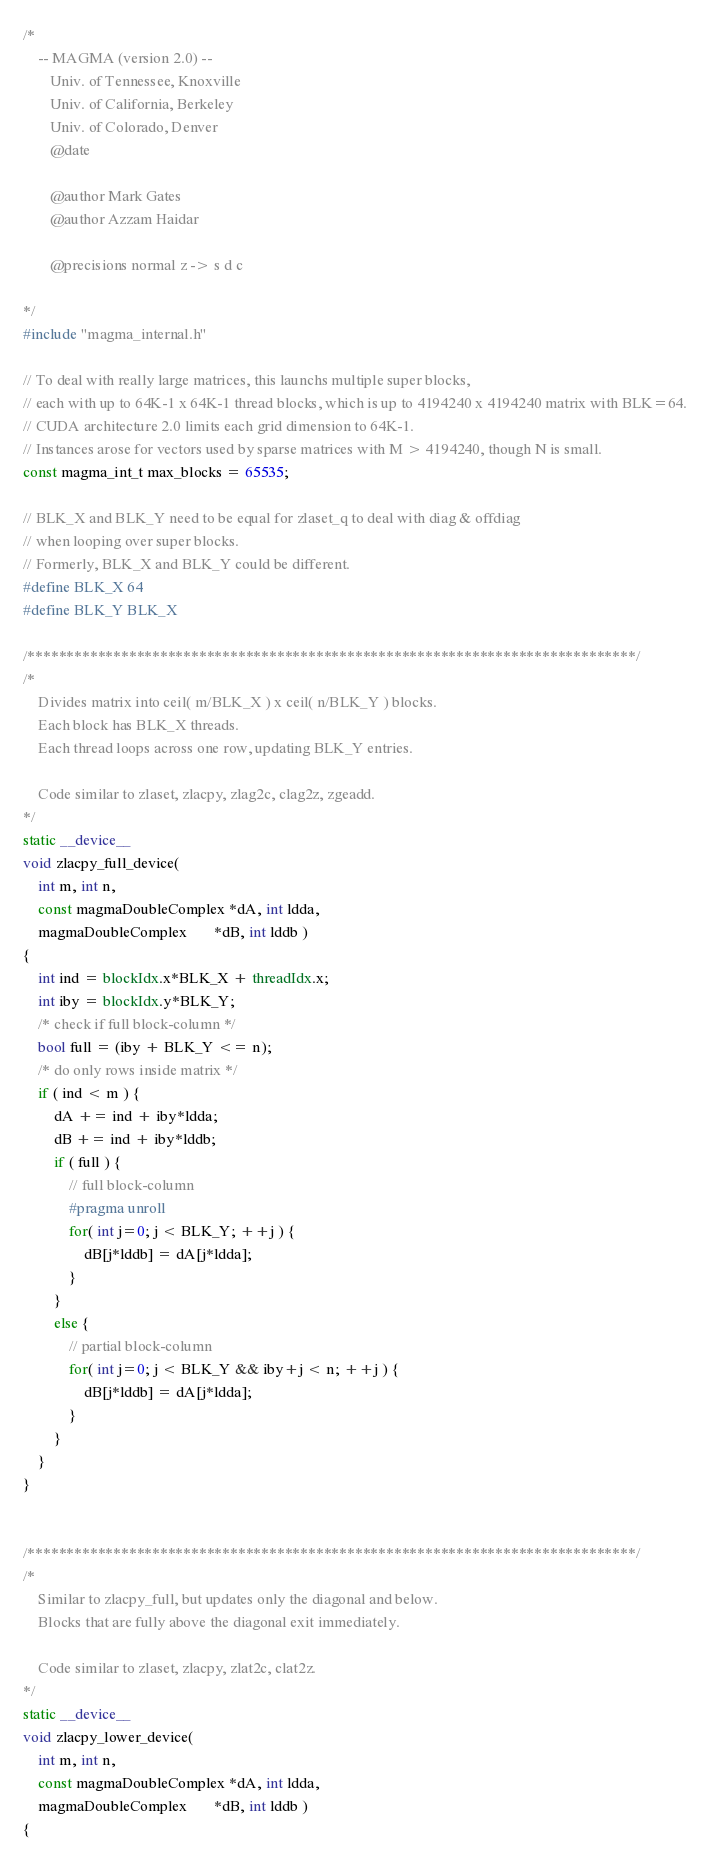Convert code to text. <code><loc_0><loc_0><loc_500><loc_500><_Cuda_>/*
    -- MAGMA (version 2.0) --
       Univ. of Tennessee, Knoxville
       Univ. of California, Berkeley
       Univ. of Colorado, Denver
       @date

       @author Mark Gates
       @author Azzam Haidar
       
       @precisions normal z -> s d c

*/
#include "magma_internal.h"

// To deal with really large matrices, this launchs multiple super blocks,
// each with up to 64K-1 x 64K-1 thread blocks, which is up to 4194240 x 4194240 matrix with BLK=64.
// CUDA architecture 2.0 limits each grid dimension to 64K-1.
// Instances arose for vectors used by sparse matrices with M > 4194240, though N is small.
const magma_int_t max_blocks = 65535;

// BLK_X and BLK_Y need to be equal for zlaset_q to deal with diag & offdiag
// when looping over super blocks.
// Formerly, BLK_X and BLK_Y could be different.
#define BLK_X 64
#define BLK_Y BLK_X

/******************************************************************************/
/*
    Divides matrix into ceil( m/BLK_X ) x ceil( n/BLK_Y ) blocks.
    Each block has BLK_X threads.
    Each thread loops across one row, updating BLK_Y entries.

    Code similar to zlaset, zlacpy, zlag2c, clag2z, zgeadd.
*/
static __device__
void zlacpy_full_device(
    int m, int n,
    const magmaDoubleComplex *dA, int ldda,
    magmaDoubleComplex       *dB, int lddb )
{
    int ind = blockIdx.x*BLK_X + threadIdx.x;
    int iby = blockIdx.y*BLK_Y;
    /* check if full block-column */
    bool full = (iby + BLK_Y <= n);
    /* do only rows inside matrix */
    if ( ind < m ) {
        dA += ind + iby*ldda;
        dB += ind + iby*lddb;
        if ( full ) {
            // full block-column
            #pragma unroll
            for( int j=0; j < BLK_Y; ++j ) {
                dB[j*lddb] = dA[j*ldda];
            }
        }
        else {
            // partial block-column
            for( int j=0; j < BLK_Y && iby+j < n; ++j ) {
                dB[j*lddb] = dA[j*ldda];
            }
        }
    }
}


/******************************************************************************/
/*
    Similar to zlacpy_full, but updates only the diagonal and below.
    Blocks that are fully above the diagonal exit immediately.

    Code similar to zlaset, zlacpy, zlat2c, clat2z.
*/
static __device__
void zlacpy_lower_device(
    int m, int n,
    const magmaDoubleComplex *dA, int ldda,
    magmaDoubleComplex       *dB, int lddb )
{</code> 